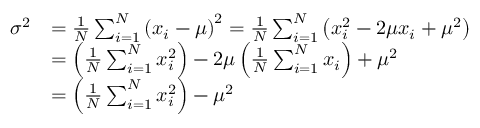<formula> <loc_0><loc_0><loc_500><loc_500>{ \begin{array} { r l } { \sigma ^ { 2 } } & { = { \frac { 1 } { N } } \sum _ { i = 1 } ^ { N } \left ( x _ { i } - \mu \right ) ^ { 2 } = { \frac { 1 } { N } } \sum _ { i = 1 } ^ { N } \left ( x _ { i } ^ { 2 } - 2 \mu x _ { i } + \mu ^ { 2 } \right ) } \\ & { = \left ( { \frac { 1 } { N } } \sum _ { i = 1 } ^ { N } x _ { i } ^ { 2 } \right ) - 2 \mu \left ( { \frac { 1 } { N } } \sum _ { i = 1 } ^ { N } x _ { i } \right ) + \mu ^ { 2 } } \\ & { = \left ( { \frac { 1 } { N } } \sum _ { i = 1 } ^ { N } x _ { i } ^ { 2 } \right ) - \mu ^ { 2 } } \end{array} }</formula> 